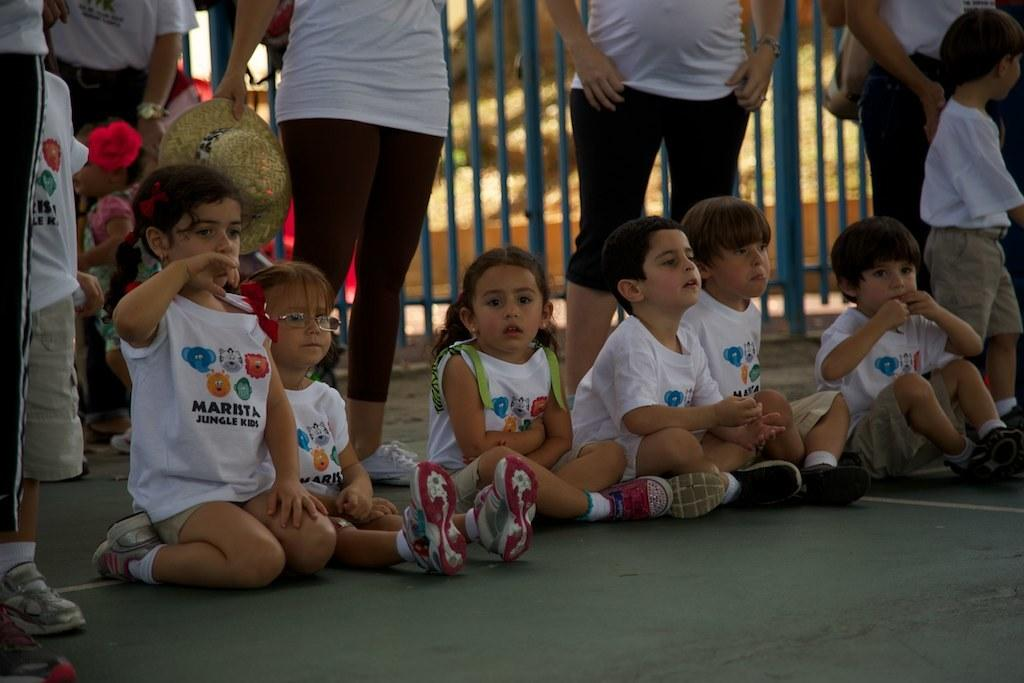What is happening in the center of the picture? There are kids sitting in the center of the picture. What can be seen in the background of the image? There are people standing in the background. How would you describe the appearance of the background? The background appears to be blurred. What type of poison is being traded among the kids in the image? There is no mention of poison or trading in the image; it features kids sitting in the center and people standing in the background. 